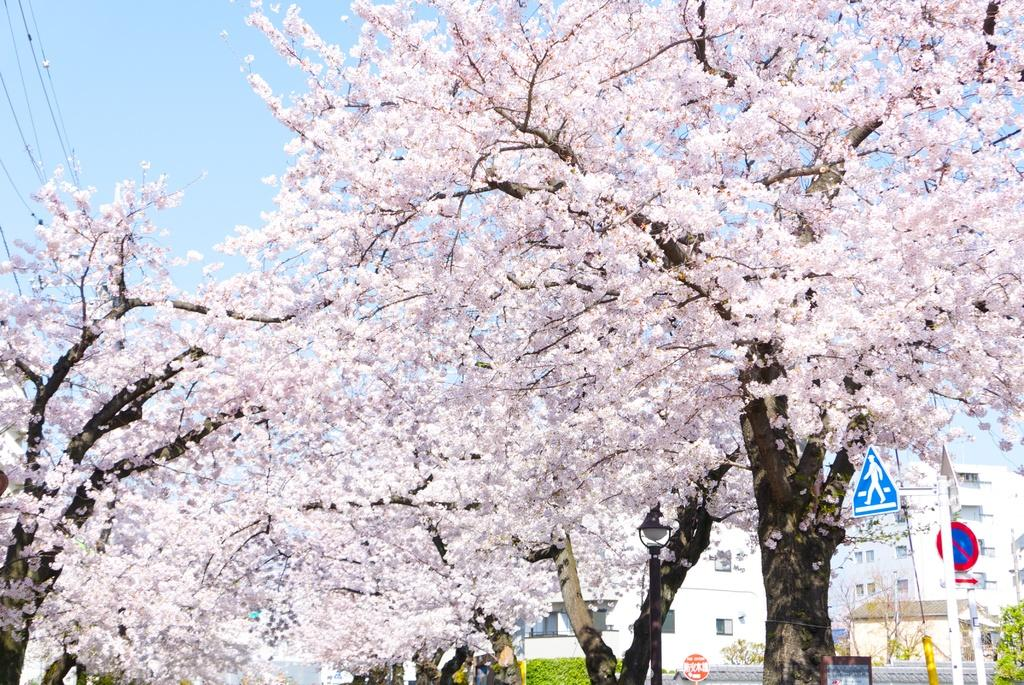What type of trees are present in the image? There are trees with pink leaves in the image. What can be seen in the background of the image? There are buildings in the background of the image. What safety measures are visible near the buildings? There are caution boards on the right side of the buildings. What is visible above the buildings in the image? The sky is visible above the buildings. How does the image compare to a nerve in terms of its structure? The image does not resemble a nerve in terms of its structure, as it features trees, buildings, and caution boards, while a nerve is a biological structure within the body. 